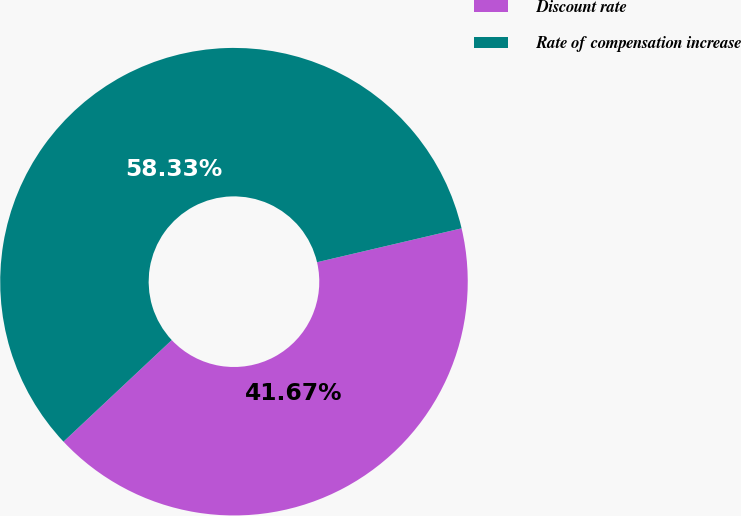<chart> <loc_0><loc_0><loc_500><loc_500><pie_chart><fcel>Discount rate<fcel>Rate of compensation increase<nl><fcel>41.67%<fcel>58.33%<nl></chart> 